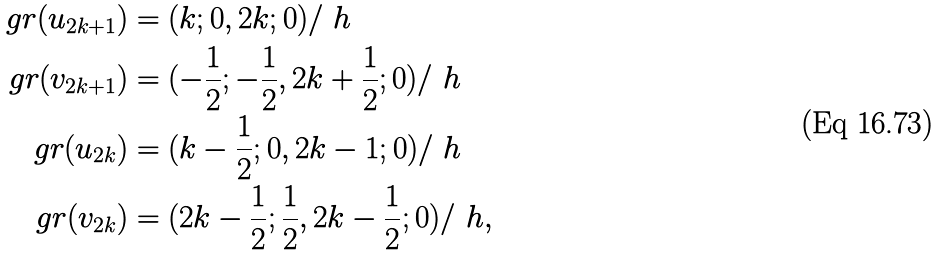<formula> <loc_0><loc_0><loc_500><loc_500>g r ( u _ { 2 k + 1 } ) & = ( k ; 0 , 2 k ; 0 ) / \ h \\ g r ( v _ { 2 k + 1 } ) & = ( - \frac { 1 } { 2 } ; - \frac { 1 } { 2 } , 2 k + \frac { 1 } { 2 } ; 0 ) / \ h \\ g r ( u _ { 2 k } ) & = ( k - \frac { 1 } { 2 } ; 0 , 2 k - 1 ; 0 ) / \ h \\ g r ( v _ { 2 k } ) & = ( 2 k - \frac { 1 } { 2 } ; \frac { 1 } { 2 } , 2 k - \frac { 1 } { 2 } ; 0 ) / \ h ,</formula> 